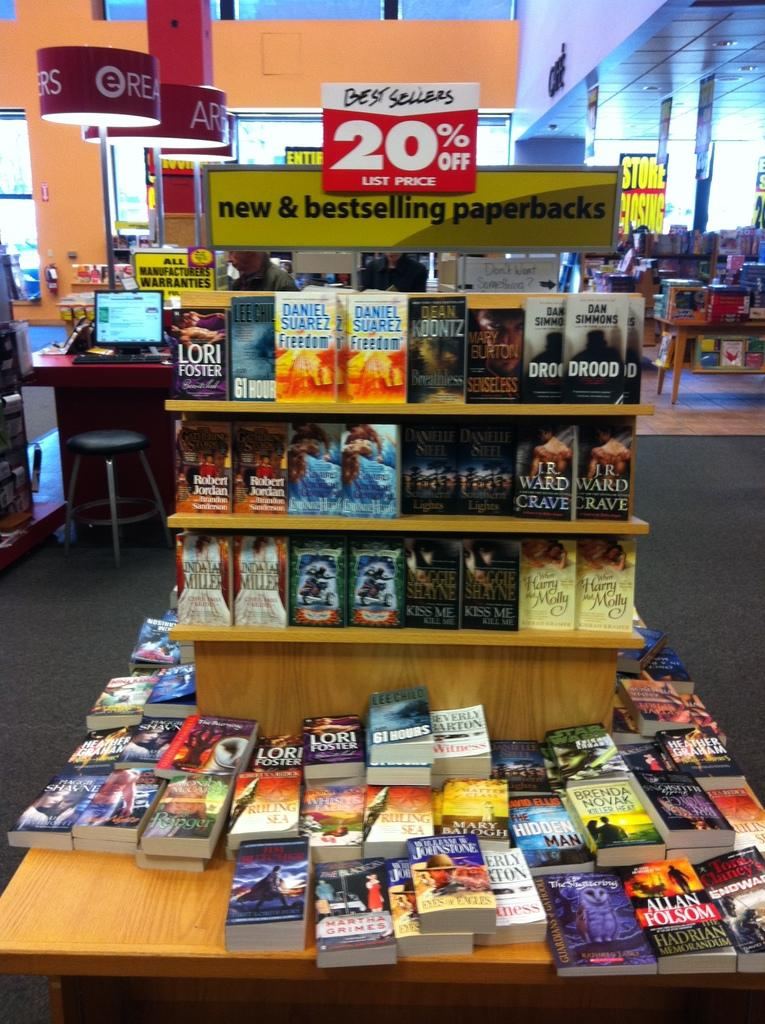<image>
Offer a succinct explanation of the picture presented. Among the bestselling paperback books is Freedom by Daniel Suarez. 